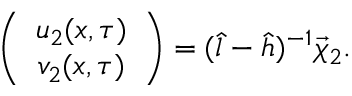Convert formula to latex. <formula><loc_0><loc_0><loc_500><loc_500>\left ( \begin{array} { c } { { u _ { 2 } ( x , \tau ) } } \\ { { v _ { 2 } ( x , \tau ) } } \end{array} \right ) = ( \hat { l } - \hat { h } ) ^ { - 1 } \vec { \chi } _ { 2 } .</formula> 